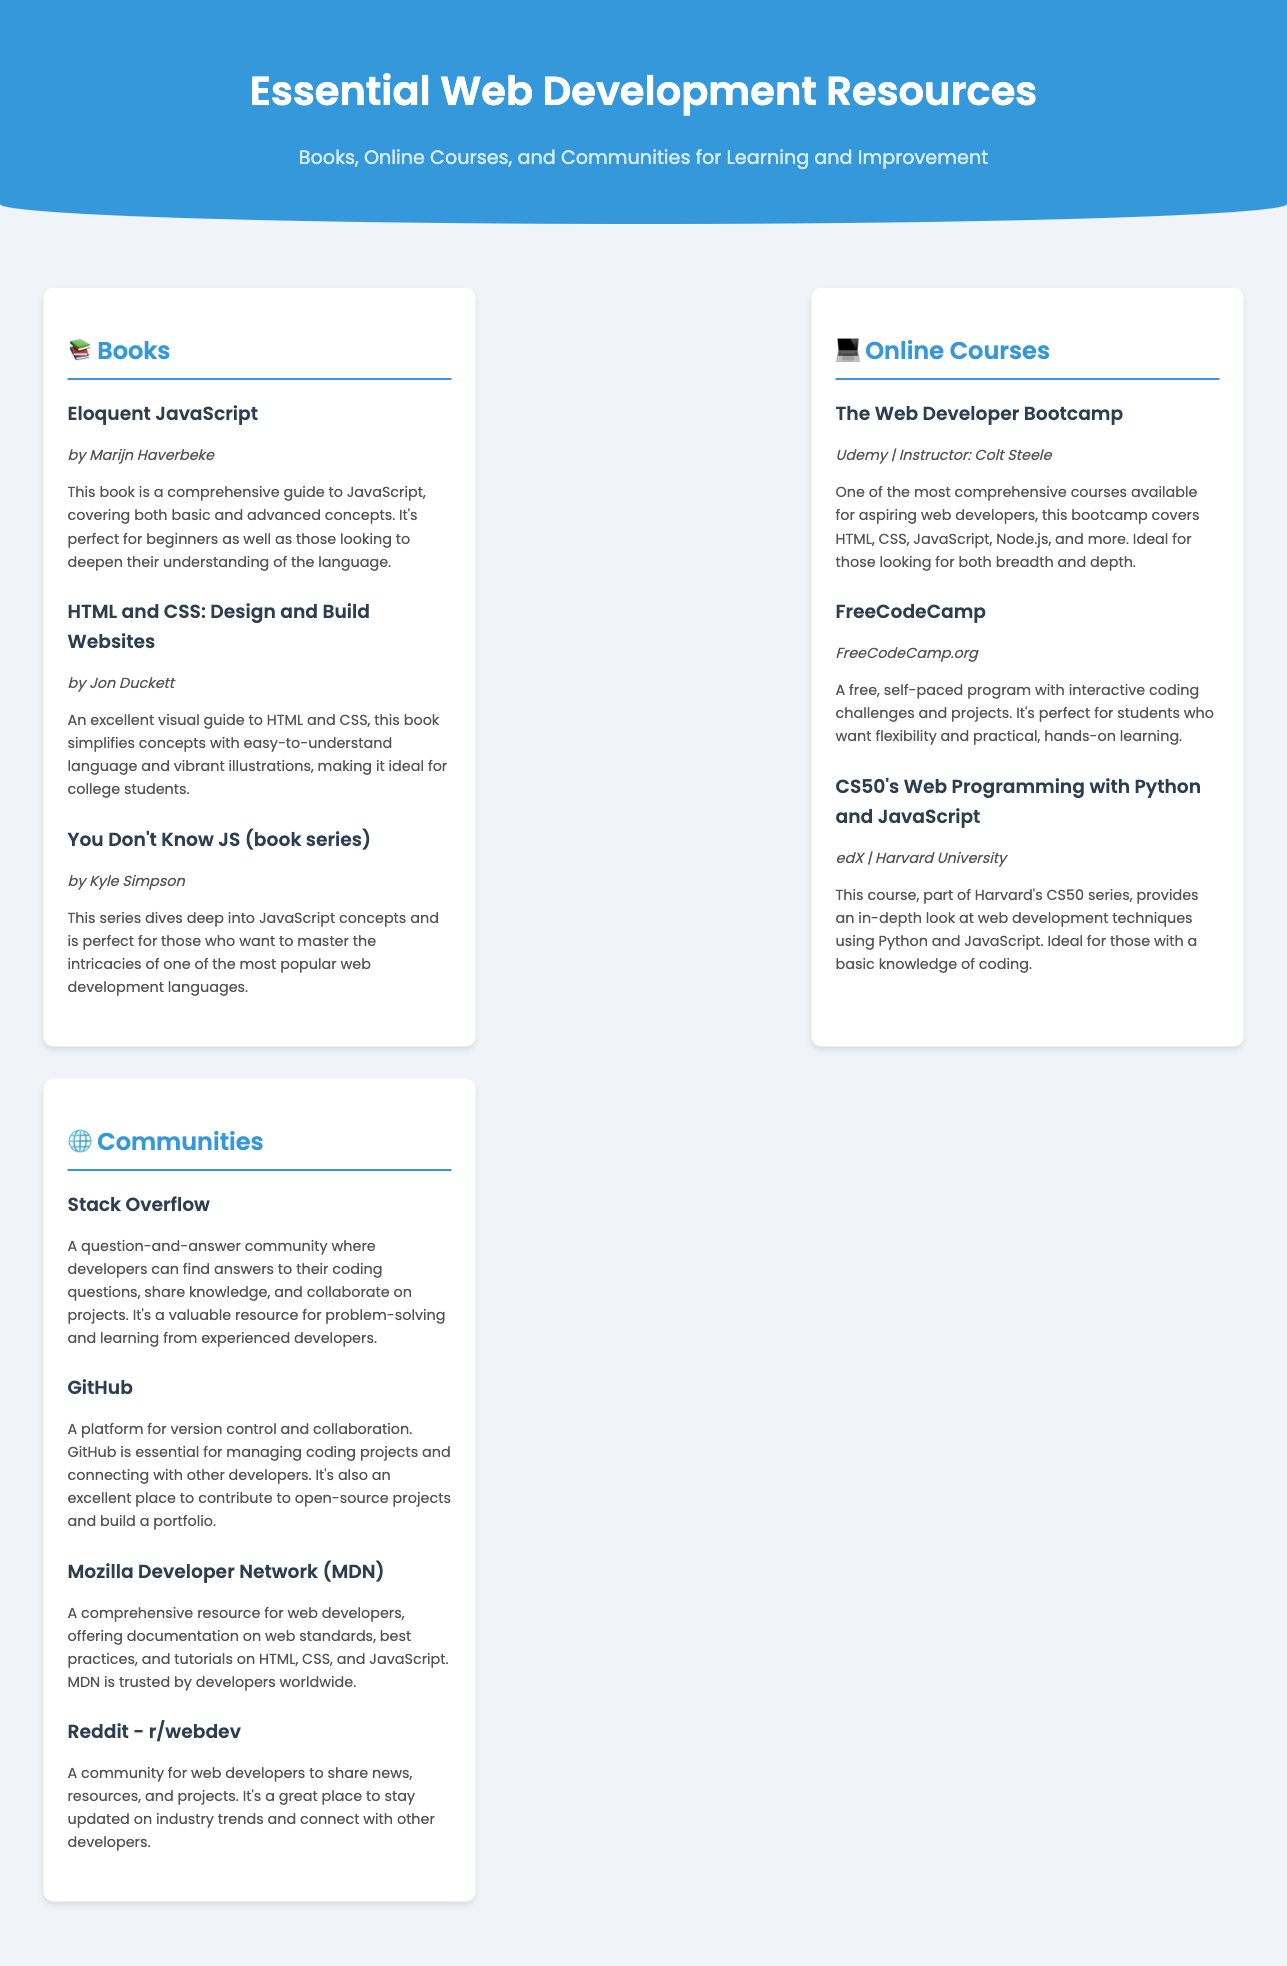What is the title of the document? The title of the document is displayed prominently in the header.
Answer: Essential Web Development Resources Who is the author of "Eloquent JavaScript"? The author of "Eloquent JavaScript" is mentioned in the book section of the document.
Answer: Marijn Haverbeke Which platform offers "The Web Developer Bootcamp"? The platform for this online course is noted in the online courses section.
Answer: Udemy What community is known for version control and collaboration? The document identifies this community under the communities section.
Answer: GitHub What series focuses on JavaScript concepts? The book series is highlighted in the books section of the document.
Answer: You Don't Know JS How many online courses are listed in the document? The document presents a total of three online courses.
Answer: 3 Which book is described as a visual guide to HTML and CSS? This information can be found in the books section, specifically for a particular book title.
Answer: HTML and CSS: Design and Build Websites What is the subtitle of the document? The subtitle is provided in the header, below the title.
Answer: Books, Online Courses, and Communities for Learning and Improvement 